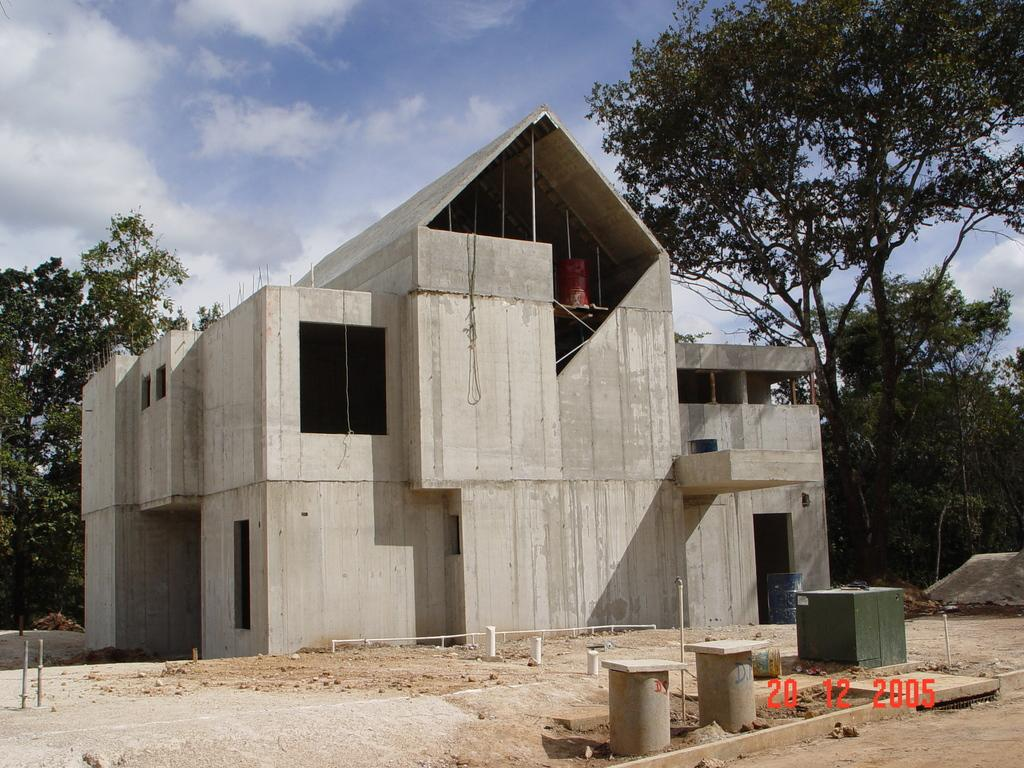What type of structures can be seen in the image? There are cement structures in the image. Is there any text or marking at the bottom of the image? Yes, a watermark is present at the bottom of the image. What type of man-made structure is visible in the image? There is a building in the image. What type of natural elements can be seen in the image? Trees are visible in the image. What is visible in the background of the image? The sky is visible in the background of the image. Can you tell me where the quicksand is located in the image? There is no quicksand present in the image. What news event is being reported in the image? The image does not depict a news event; it shows cement structures, a building, trees, and the sky. 